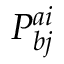Convert formula to latex. <formula><loc_0><loc_0><loc_500><loc_500>P _ { b j } ^ { a i }</formula> 